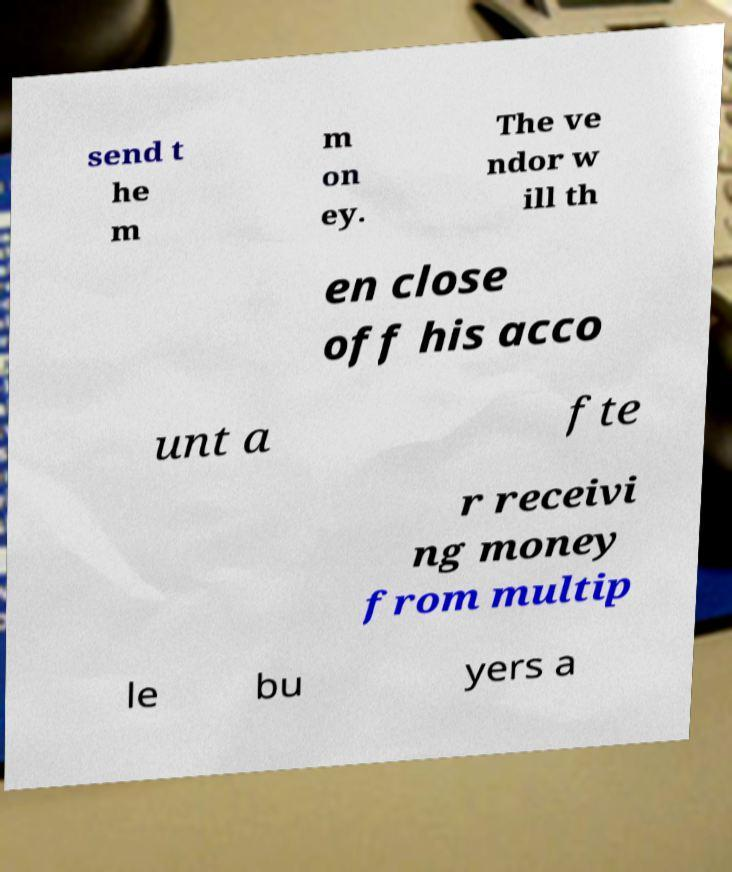Please identify and transcribe the text found in this image. send t he m m on ey. The ve ndor w ill th en close off his acco unt a fte r receivi ng money from multip le bu yers a 